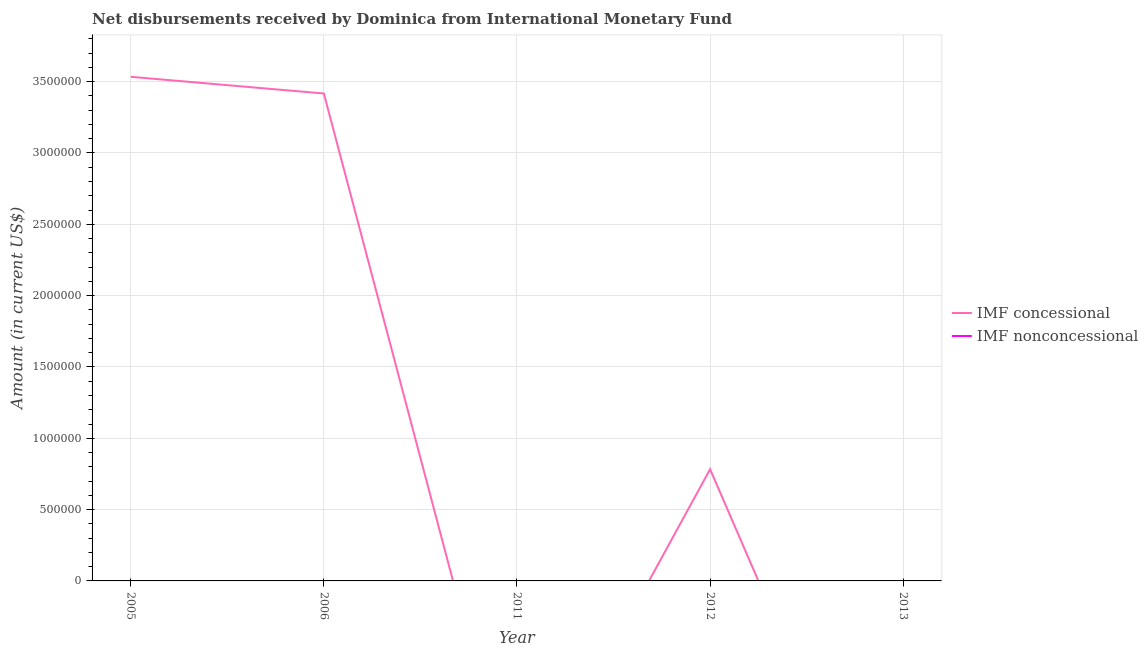How many different coloured lines are there?
Offer a very short reply. 1. What is the net concessional disbursements from imf in 2012?
Provide a short and direct response. 7.83e+05. Across all years, what is the maximum net concessional disbursements from imf?
Your answer should be very brief. 3.53e+06. What is the total net concessional disbursements from imf in the graph?
Ensure brevity in your answer.  7.73e+06. What is the difference between the net concessional disbursements from imf in 2005 and that in 2006?
Offer a very short reply. 1.17e+05. What is the difference between the net non concessional disbursements from imf in 2005 and the net concessional disbursements from imf in 2006?
Offer a terse response. -3.42e+06. In how many years, is the net concessional disbursements from imf greater than 800000 US$?
Your answer should be very brief. 2. Is the net concessional disbursements from imf in 2006 less than that in 2012?
Keep it short and to the point. No. What is the difference between the highest and the second highest net concessional disbursements from imf?
Your answer should be very brief. 1.17e+05. What is the difference between the highest and the lowest net concessional disbursements from imf?
Keep it short and to the point. 3.53e+06. Is the net non concessional disbursements from imf strictly greater than the net concessional disbursements from imf over the years?
Provide a succinct answer. No. Is the net concessional disbursements from imf strictly less than the net non concessional disbursements from imf over the years?
Offer a terse response. No. How many lines are there?
Offer a terse response. 1. Does the graph contain any zero values?
Ensure brevity in your answer.  Yes. Does the graph contain grids?
Provide a short and direct response. Yes. Where does the legend appear in the graph?
Offer a terse response. Center right. How many legend labels are there?
Ensure brevity in your answer.  2. How are the legend labels stacked?
Your answer should be compact. Vertical. What is the title of the graph?
Your answer should be compact. Net disbursements received by Dominica from International Monetary Fund. Does "Domestic liabilities" appear as one of the legend labels in the graph?
Your response must be concise. No. What is the label or title of the Y-axis?
Your response must be concise. Amount (in current US$). What is the Amount (in current US$) of IMF concessional in 2005?
Your answer should be very brief. 3.53e+06. What is the Amount (in current US$) of IMF nonconcessional in 2005?
Your answer should be compact. 0. What is the Amount (in current US$) in IMF concessional in 2006?
Make the answer very short. 3.42e+06. What is the Amount (in current US$) of IMF concessional in 2011?
Keep it short and to the point. 0. What is the Amount (in current US$) of IMF nonconcessional in 2011?
Provide a short and direct response. 0. What is the Amount (in current US$) in IMF concessional in 2012?
Keep it short and to the point. 7.83e+05. What is the Amount (in current US$) of IMF nonconcessional in 2012?
Provide a short and direct response. 0. What is the Amount (in current US$) of IMF concessional in 2013?
Provide a succinct answer. 0. Across all years, what is the maximum Amount (in current US$) in IMF concessional?
Your answer should be very brief. 3.53e+06. What is the total Amount (in current US$) in IMF concessional in the graph?
Offer a terse response. 7.73e+06. What is the total Amount (in current US$) in IMF nonconcessional in the graph?
Your response must be concise. 0. What is the difference between the Amount (in current US$) of IMF concessional in 2005 and that in 2006?
Your answer should be very brief. 1.17e+05. What is the difference between the Amount (in current US$) of IMF concessional in 2005 and that in 2012?
Your response must be concise. 2.75e+06. What is the difference between the Amount (in current US$) of IMF concessional in 2006 and that in 2012?
Your answer should be very brief. 2.63e+06. What is the average Amount (in current US$) in IMF concessional per year?
Offer a terse response. 1.55e+06. What is the average Amount (in current US$) in IMF nonconcessional per year?
Give a very brief answer. 0. What is the ratio of the Amount (in current US$) in IMF concessional in 2005 to that in 2006?
Give a very brief answer. 1.03. What is the ratio of the Amount (in current US$) in IMF concessional in 2005 to that in 2012?
Ensure brevity in your answer.  4.51. What is the ratio of the Amount (in current US$) in IMF concessional in 2006 to that in 2012?
Provide a succinct answer. 4.36. What is the difference between the highest and the second highest Amount (in current US$) of IMF concessional?
Make the answer very short. 1.17e+05. What is the difference between the highest and the lowest Amount (in current US$) in IMF concessional?
Your answer should be compact. 3.53e+06. 